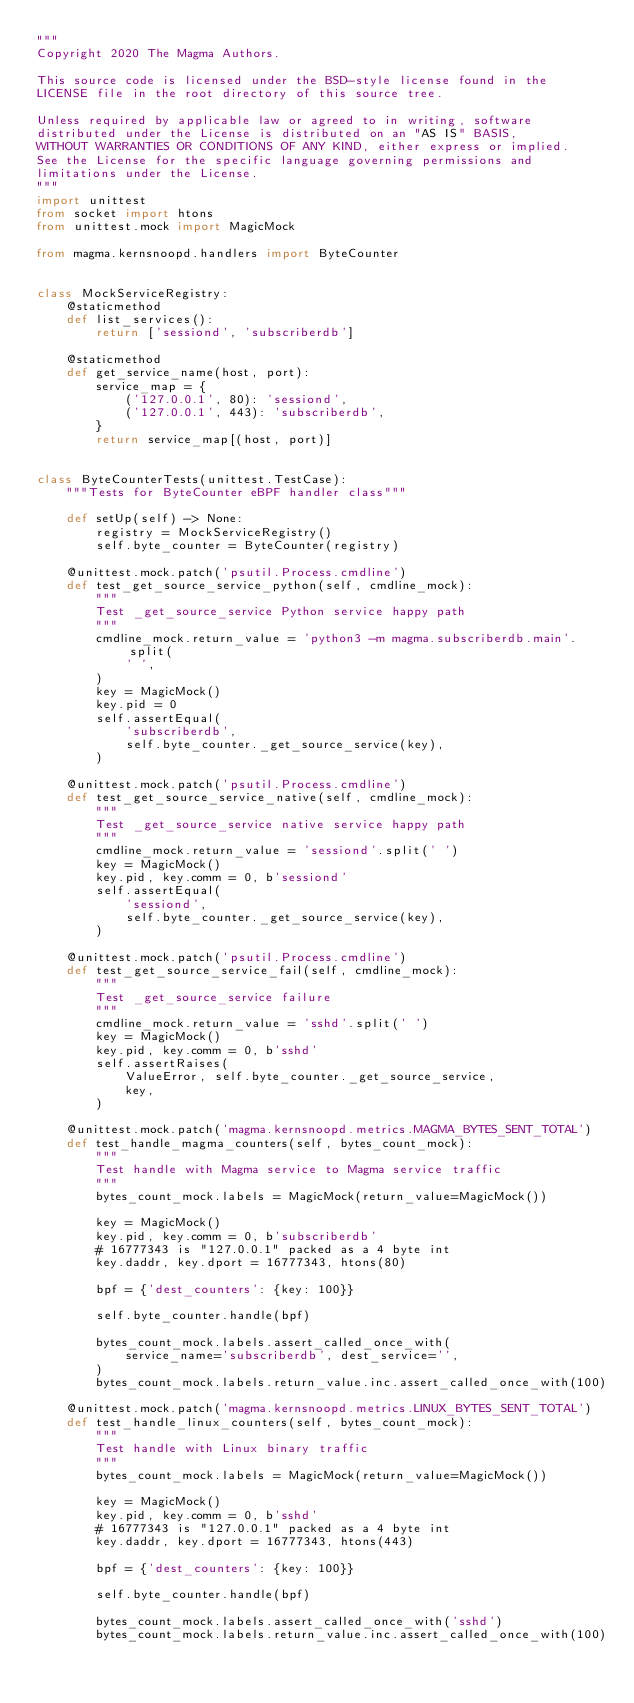Convert code to text. <code><loc_0><loc_0><loc_500><loc_500><_Python_>"""
Copyright 2020 The Magma Authors.

This source code is licensed under the BSD-style license found in the
LICENSE file in the root directory of this source tree.

Unless required by applicable law or agreed to in writing, software
distributed under the License is distributed on an "AS IS" BASIS,
WITHOUT WARRANTIES OR CONDITIONS OF ANY KIND, either express or implied.
See the License for the specific language governing permissions and
limitations under the License.
"""
import unittest
from socket import htons
from unittest.mock import MagicMock

from magma.kernsnoopd.handlers import ByteCounter


class MockServiceRegistry:
    @staticmethod
    def list_services():
        return ['sessiond', 'subscriberdb']

    @staticmethod
    def get_service_name(host, port):
        service_map = {
            ('127.0.0.1', 80): 'sessiond',
            ('127.0.0.1', 443): 'subscriberdb',
        }
        return service_map[(host, port)]


class ByteCounterTests(unittest.TestCase):
    """Tests for ByteCounter eBPF handler class"""

    def setUp(self) -> None:
        registry = MockServiceRegistry()
        self.byte_counter = ByteCounter(registry)

    @unittest.mock.patch('psutil.Process.cmdline')
    def test_get_source_service_python(self, cmdline_mock):
        """
        Test _get_source_service Python service happy path
        """
        cmdline_mock.return_value = 'python3 -m magma.subscriberdb.main'.split(
            ' ',
        )
        key = MagicMock()
        key.pid = 0
        self.assertEqual(
            'subscriberdb',
            self.byte_counter._get_source_service(key),
        )

    @unittest.mock.patch('psutil.Process.cmdline')
    def test_get_source_service_native(self, cmdline_mock):
        """
        Test _get_source_service native service happy path
        """
        cmdline_mock.return_value = 'sessiond'.split(' ')
        key = MagicMock()
        key.pid, key.comm = 0, b'sessiond'
        self.assertEqual(
            'sessiond',
            self.byte_counter._get_source_service(key),
        )

    @unittest.mock.patch('psutil.Process.cmdline')
    def test_get_source_service_fail(self, cmdline_mock):
        """
        Test _get_source_service failure
        """
        cmdline_mock.return_value = 'sshd'.split(' ')
        key = MagicMock()
        key.pid, key.comm = 0, b'sshd'
        self.assertRaises(
            ValueError, self.byte_counter._get_source_service,
            key,
        )

    @unittest.mock.patch('magma.kernsnoopd.metrics.MAGMA_BYTES_SENT_TOTAL')
    def test_handle_magma_counters(self, bytes_count_mock):
        """
        Test handle with Magma service to Magma service traffic
        """
        bytes_count_mock.labels = MagicMock(return_value=MagicMock())

        key = MagicMock()
        key.pid, key.comm = 0, b'subscriberdb'
        # 16777343 is "127.0.0.1" packed as a 4 byte int
        key.daddr, key.dport = 16777343, htons(80)

        bpf = {'dest_counters': {key: 100}}

        self.byte_counter.handle(bpf)

        bytes_count_mock.labels.assert_called_once_with(
            service_name='subscriberdb', dest_service='',
        )
        bytes_count_mock.labels.return_value.inc.assert_called_once_with(100)

    @unittest.mock.patch('magma.kernsnoopd.metrics.LINUX_BYTES_SENT_TOTAL')
    def test_handle_linux_counters(self, bytes_count_mock):
        """
        Test handle with Linux binary traffic
        """
        bytes_count_mock.labels = MagicMock(return_value=MagicMock())

        key = MagicMock()
        key.pid, key.comm = 0, b'sshd'
        # 16777343 is "127.0.0.1" packed as a 4 byte int
        key.daddr, key.dport = 16777343, htons(443)

        bpf = {'dest_counters': {key: 100}}

        self.byte_counter.handle(bpf)

        bytes_count_mock.labels.assert_called_once_with('sshd')
        bytes_count_mock.labels.return_value.inc.assert_called_once_with(100)
</code> 